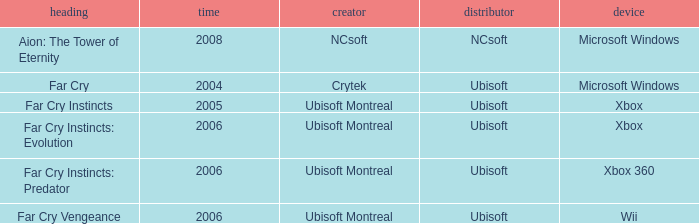Which title has a year prior to 2008 and xbox 360 as the platform? Far Cry Instincts: Predator. 